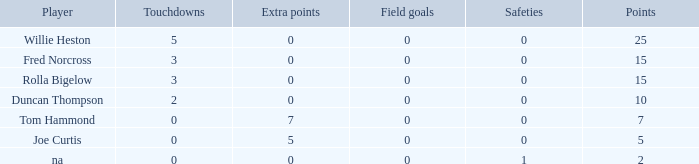How many touchdowns has a player of rolla bigelow scored, and an extra points fewer than 0? None. 